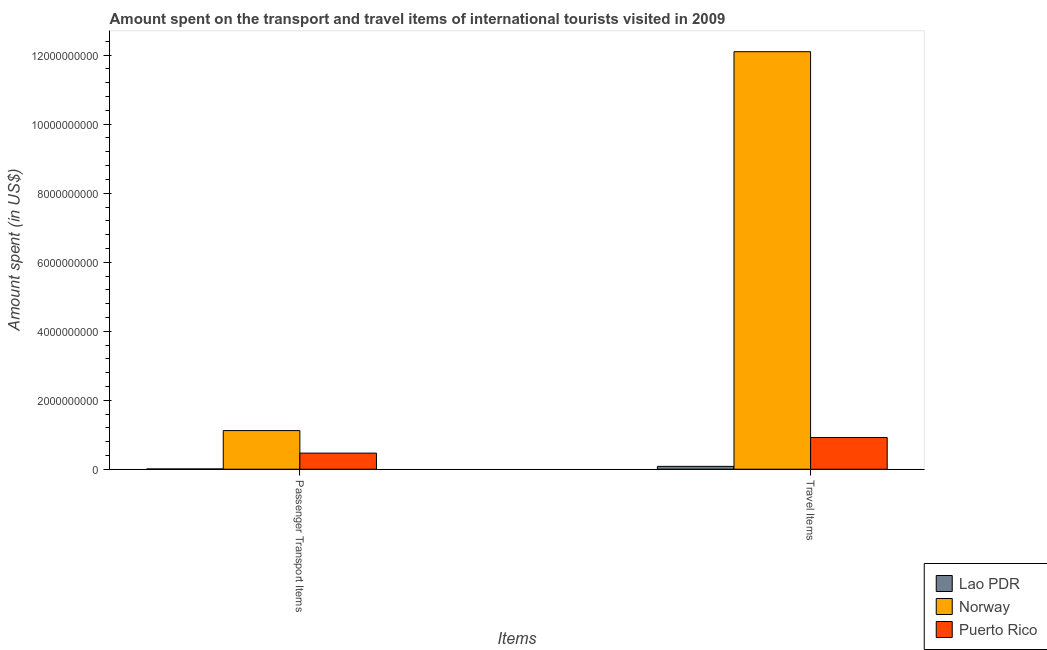How many different coloured bars are there?
Offer a terse response. 3. How many bars are there on the 1st tick from the left?
Offer a very short reply. 3. How many bars are there on the 1st tick from the right?
Make the answer very short. 3. What is the label of the 2nd group of bars from the left?
Offer a very short reply. Travel Items. What is the amount spent on passenger transport items in Norway?
Your response must be concise. 1.12e+09. Across all countries, what is the maximum amount spent in travel items?
Provide a short and direct response. 1.21e+1. Across all countries, what is the minimum amount spent in travel items?
Your answer should be very brief. 8.30e+07. In which country was the amount spent in travel items maximum?
Your answer should be very brief. Norway. In which country was the amount spent in travel items minimum?
Your answer should be very brief. Lao PDR. What is the total amount spent in travel items in the graph?
Keep it short and to the point. 1.31e+1. What is the difference between the amount spent on passenger transport items in Puerto Rico and that in Norway?
Make the answer very short. -6.53e+08. What is the difference between the amount spent on passenger transport items in Norway and the amount spent in travel items in Puerto Rico?
Give a very brief answer. 2.01e+08. What is the average amount spent on passenger transport items per country?
Your answer should be very brief. 5.32e+08. What is the difference between the amount spent on passenger transport items and amount spent in travel items in Norway?
Your answer should be compact. -1.10e+1. What is the ratio of the amount spent on passenger transport items in Norway to that in Puerto Rico?
Offer a very short reply. 2.4. What does the 3rd bar from the left in Passenger Transport Items represents?
Give a very brief answer. Puerto Rico. What does the 3rd bar from the right in Passenger Transport Items represents?
Give a very brief answer. Lao PDR. Where does the legend appear in the graph?
Provide a succinct answer. Bottom right. How are the legend labels stacked?
Keep it short and to the point. Vertical. What is the title of the graph?
Keep it short and to the point. Amount spent on the transport and travel items of international tourists visited in 2009. What is the label or title of the X-axis?
Offer a very short reply. Items. What is the label or title of the Y-axis?
Keep it short and to the point. Amount spent (in US$). What is the Amount spent (in US$) of Norway in Passenger Transport Items?
Your response must be concise. 1.12e+09. What is the Amount spent (in US$) in Puerto Rico in Passenger Transport Items?
Your response must be concise. 4.67e+08. What is the Amount spent (in US$) of Lao PDR in Travel Items?
Keep it short and to the point. 8.30e+07. What is the Amount spent (in US$) of Norway in Travel Items?
Offer a terse response. 1.21e+1. What is the Amount spent (in US$) in Puerto Rico in Travel Items?
Offer a very short reply. 9.19e+08. Across all Items, what is the maximum Amount spent (in US$) in Lao PDR?
Make the answer very short. 8.30e+07. Across all Items, what is the maximum Amount spent (in US$) of Norway?
Your response must be concise. 1.21e+1. Across all Items, what is the maximum Amount spent (in US$) of Puerto Rico?
Offer a terse response. 9.19e+08. Across all Items, what is the minimum Amount spent (in US$) in Norway?
Your answer should be compact. 1.12e+09. Across all Items, what is the minimum Amount spent (in US$) in Puerto Rico?
Keep it short and to the point. 4.67e+08. What is the total Amount spent (in US$) in Lao PDR in the graph?
Offer a terse response. 9.10e+07. What is the total Amount spent (in US$) of Norway in the graph?
Offer a terse response. 1.32e+1. What is the total Amount spent (in US$) in Puerto Rico in the graph?
Provide a short and direct response. 1.39e+09. What is the difference between the Amount spent (in US$) in Lao PDR in Passenger Transport Items and that in Travel Items?
Provide a succinct answer. -7.50e+07. What is the difference between the Amount spent (in US$) of Norway in Passenger Transport Items and that in Travel Items?
Ensure brevity in your answer.  -1.10e+1. What is the difference between the Amount spent (in US$) of Puerto Rico in Passenger Transport Items and that in Travel Items?
Your answer should be compact. -4.52e+08. What is the difference between the Amount spent (in US$) of Lao PDR in Passenger Transport Items and the Amount spent (in US$) of Norway in Travel Items?
Offer a very short reply. -1.21e+1. What is the difference between the Amount spent (in US$) of Lao PDR in Passenger Transport Items and the Amount spent (in US$) of Puerto Rico in Travel Items?
Make the answer very short. -9.11e+08. What is the difference between the Amount spent (in US$) in Norway in Passenger Transport Items and the Amount spent (in US$) in Puerto Rico in Travel Items?
Keep it short and to the point. 2.01e+08. What is the average Amount spent (in US$) in Lao PDR per Items?
Offer a terse response. 4.55e+07. What is the average Amount spent (in US$) of Norway per Items?
Provide a short and direct response. 6.61e+09. What is the average Amount spent (in US$) of Puerto Rico per Items?
Provide a short and direct response. 6.93e+08. What is the difference between the Amount spent (in US$) of Lao PDR and Amount spent (in US$) of Norway in Passenger Transport Items?
Ensure brevity in your answer.  -1.11e+09. What is the difference between the Amount spent (in US$) in Lao PDR and Amount spent (in US$) in Puerto Rico in Passenger Transport Items?
Provide a succinct answer. -4.59e+08. What is the difference between the Amount spent (in US$) in Norway and Amount spent (in US$) in Puerto Rico in Passenger Transport Items?
Your answer should be compact. 6.53e+08. What is the difference between the Amount spent (in US$) in Lao PDR and Amount spent (in US$) in Norway in Travel Items?
Ensure brevity in your answer.  -1.20e+1. What is the difference between the Amount spent (in US$) of Lao PDR and Amount spent (in US$) of Puerto Rico in Travel Items?
Keep it short and to the point. -8.36e+08. What is the difference between the Amount spent (in US$) in Norway and Amount spent (in US$) in Puerto Rico in Travel Items?
Your answer should be very brief. 1.12e+1. What is the ratio of the Amount spent (in US$) in Lao PDR in Passenger Transport Items to that in Travel Items?
Keep it short and to the point. 0.1. What is the ratio of the Amount spent (in US$) of Norway in Passenger Transport Items to that in Travel Items?
Your answer should be very brief. 0.09. What is the ratio of the Amount spent (in US$) in Puerto Rico in Passenger Transport Items to that in Travel Items?
Your answer should be compact. 0.51. What is the difference between the highest and the second highest Amount spent (in US$) of Lao PDR?
Keep it short and to the point. 7.50e+07. What is the difference between the highest and the second highest Amount spent (in US$) of Norway?
Offer a very short reply. 1.10e+1. What is the difference between the highest and the second highest Amount spent (in US$) in Puerto Rico?
Your response must be concise. 4.52e+08. What is the difference between the highest and the lowest Amount spent (in US$) of Lao PDR?
Offer a very short reply. 7.50e+07. What is the difference between the highest and the lowest Amount spent (in US$) in Norway?
Your answer should be very brief. 1.10e+1. What is the difference between the highest and the lowest Amount spent (in US$) of Puerto Rico?
Offer a terse response. 4.52e+08. 